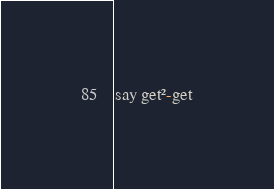Convert code to text. <code><loc_0><loc_0><loc_500><loc_500><_Perl_>say get²-get</code> 